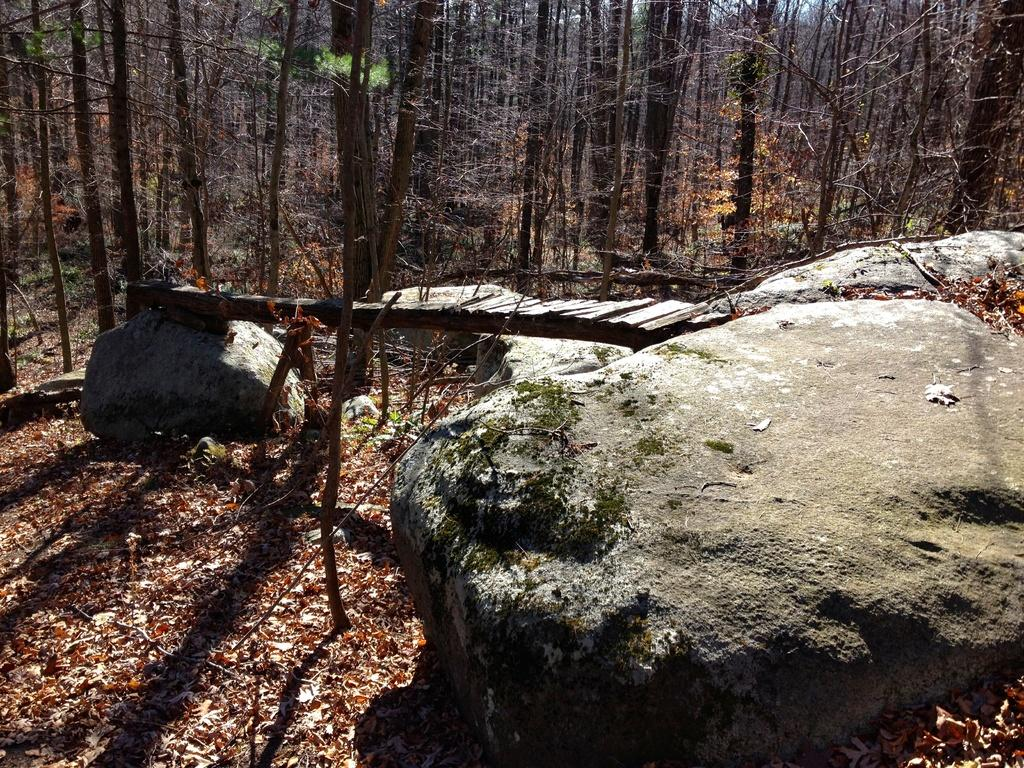What type of natural elements can be seen in the image? There are rocks in the image. What can be seen in the background of the image? There are dried trees in the background of the image. What is the color of the sky in the image? The sky appears to be white in color. What type of pan is being used by the police officer in the image? There are no police officers or pans present in the image. 